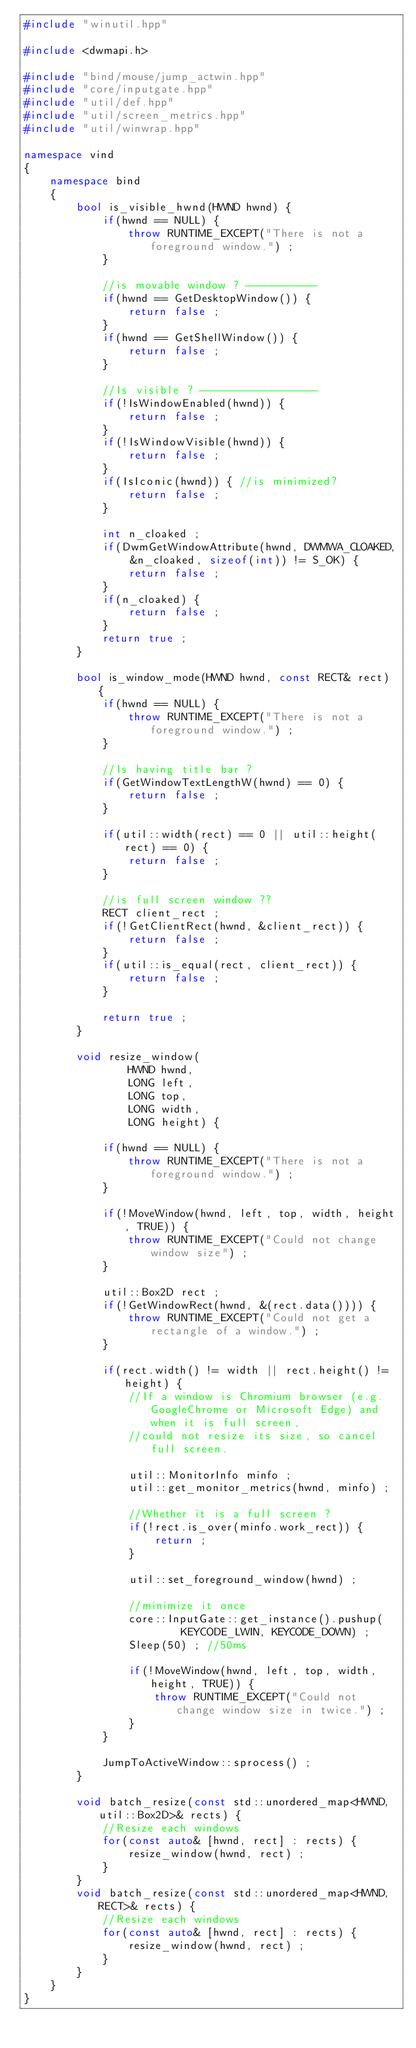<code> <loc_0><loc_0><loc_500><loc_500><_C++_>#include "winutil.hpp"

#include <dwmapi.h>

#include "bind/mouse/jump_actwin.hpp"
#include "core/inputgate.hpp"
#include "util/def.hpp"
#include "util/screen_metrics.hpp"
#include "util/winwrap.hpp"

namespace vind
{
    namespace bind
    {
        bool is_visible_hwnd(HWND hwnd) {
            if(hwnd == NULL) {
                throw RUNTIME_EXCEPT("There is not a foreground window.") ;
            }

            //is movable window ? -----------
            if(hwnd == GetDesktopWindow()) {
                return false ;
            }
            if(hwnd == GetShellWindow()) {
                return false ;
            }

            //Is visible ? ------------------
            if(!IsWindowEnabled(hwnd)) {
                return false ;
            }
            if(!IsWindowVisible(hwnd)) {
                return false ;
            }
            if(IsIconic(hwnd)) { //is minimized?
                return false ;
            }

            int n_cloaked ;
            if(DwmGetWindowAttribute(hwnd, DWMWA_CLOAKED, &n_cloaked, sizeof(int)) != S_OK) {
                return false ;
            }
            if(n_cloaked) {
                return false ;
            }
            return true ;
        }

        bool is_window_mode(HWND hwnd, const RECT& rect) {
            if(hwnd == NULL) {
                throw RUNTIME_EXCEPT("There is not a foreground window.") ;
            }

            //Is having title bar ?
            if(GetWindowTextLengthW(hwnd) == 0) {
                return false ;
            }

            if(util::width(rect) == 0 || util::height(rect) == 0) {
                return false ;
            }

            //is full screen window ??
            RECT client_rect ;
            if(!GetClientRect(hwnd, &client_rect)) {
                return false ;
            }
            if(util::is_equal(rect, client_rect)) {
                return false ;
            }

            return true ;
        }

        void resize_window(
                HWND hwnd,
                LONG left,
                LONG top,
                LONG width,
                LONG height) {

            if(hwnd == NULL) {
                throw RUNTIME_EXCEPT("There is not a foreground window.") ;
            }

            if(!MoveWindow(hwnd, left, top, width, height, TRUE)) {
                throw RUNTIME_EXCEPT("Could not change window size") ;
            }

            util::Box2D rect ;
            if(!GetWindowRect(hwnd, &(rect.data()))) {
                throw RUNTIME_EXCEPT("Could not get a rectangle of a window.") ;
            }

            if(rect.width() != width || rect.height() != height) {
                //If a window is Chromium browser (e.g. GoogleChrome or Microsoft Edge) and when it is full screen,
                //could not resize its size, so cancel full screen.

                util::MonitorInfo minfo ;
                util::get_monitor_metrics(hwnd, minfo) ;

                //Whether it is a full screen ?
                if(!rect.is_over(minfo.work_rect)) {
                    return ;
                }

                util::set_foreground_window(hwnd) ;

                //minimize it once
                core::InputGate::get_instance().pushup(
                        KEYCODE_LWIN, KEYCODE_DOWN) ;
                Sleep(50) ; //50ms

                if(!MoveWindow(hwnd, left, top, width, height, TRUE)) {
                    throw RUNTIME_EXCEPT("Could not change window size in twice.") ;
                }
            }

            JumpToActiveWindow::sprocess() ;
        }

        void batch_resize(const std::unordered_map<HWND, util::Box2D>& rects) {
            //Resize each windows
            for(const auto& [hwnd, rect] : rects) {
                resize_window(hwnd, rect) ;
            }
        }
        void batch_resize(const std::unordered_map<HWND, RECT>& rects) {
            //Resize each windows
            for(const auto& [hwnd, rect] : rects) {
                resize_window(hwnd, rect) ;
            }
        }
    }
}
</code> 